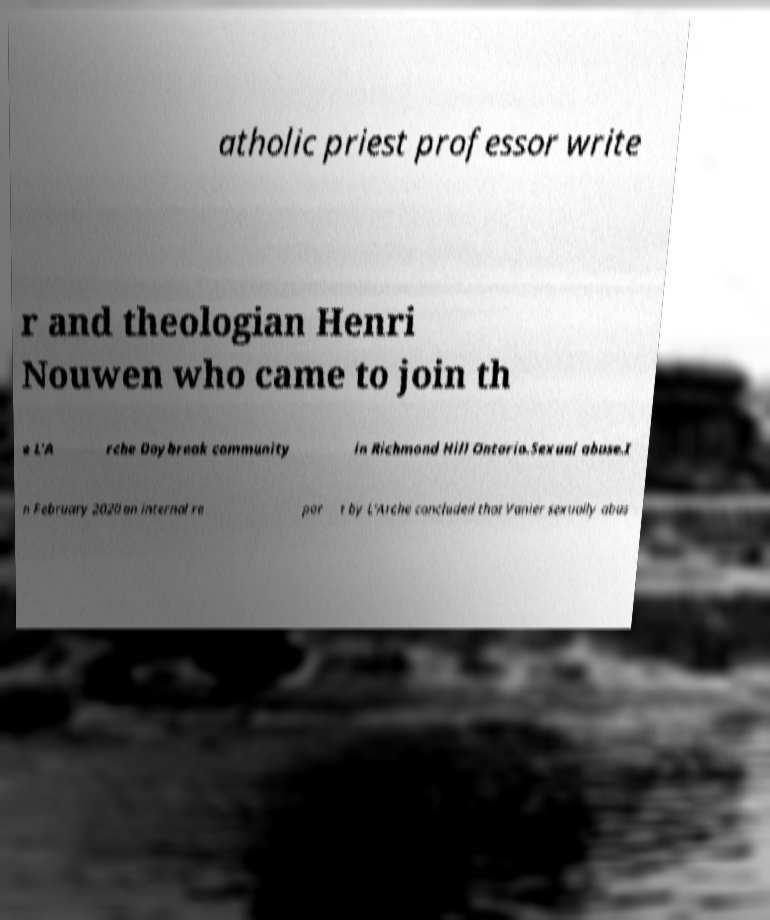There's text embedded in this image that I need extracted. Can you transcribe it verbatim? atholic priest professor write r and theologian Henri Nouwen who came to join th e L'A rche Daybreak community in Richmond Hill Ontario.Sexual abuse.I n February 2020 an internal re por t by L'Arche concluded that Vanier sexually abus 